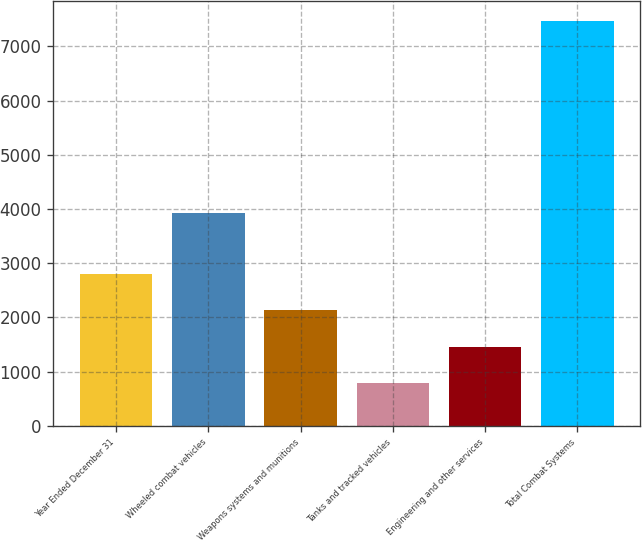<chart> <loc_0><loc_0><loc_500><loc_500><bar_chart><fcel>Year Ended December 31<fcel>Wheeled combat vehicles<fcel>Weapons systems and munitions<fcel>Tanks and tracked vehicles<fcel>Engineering and other services<fcel>Total Combat Systems<nl><fcel>2795.7<fcel>3930<fcel>2127.8<fcel>792<fcel>1459.9<fcel>7471<nl></chart> 